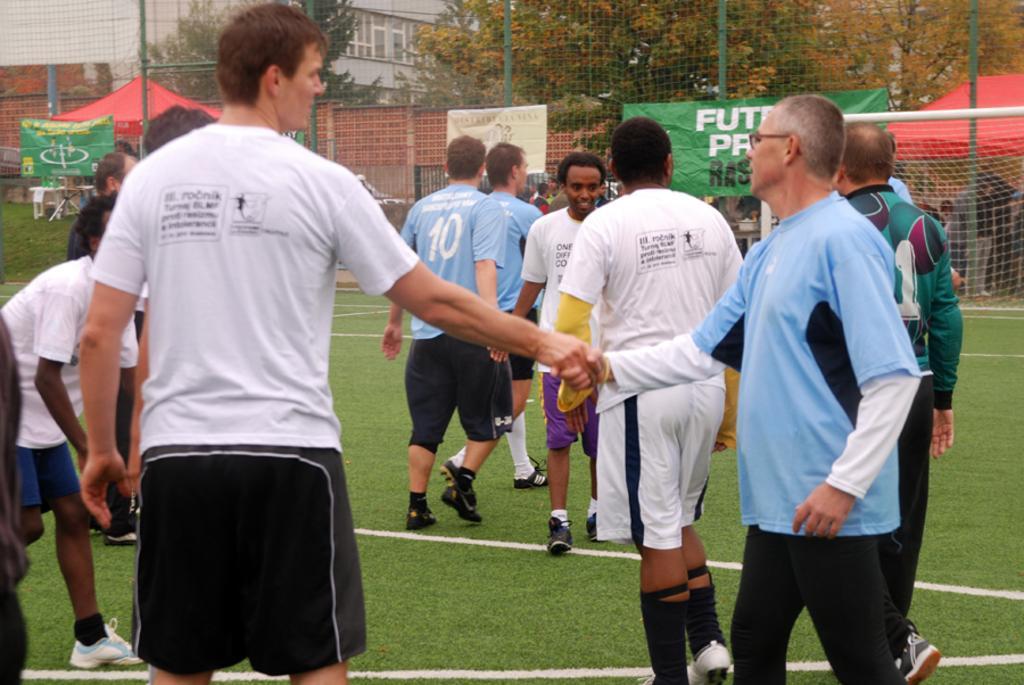Please provide a concise description of this image. In this picture we can see a group of people on the grass. In front of the people, it looks like mesh and there are poles and banners. Behind the mesh there are some people, stalls, trees and a building. 